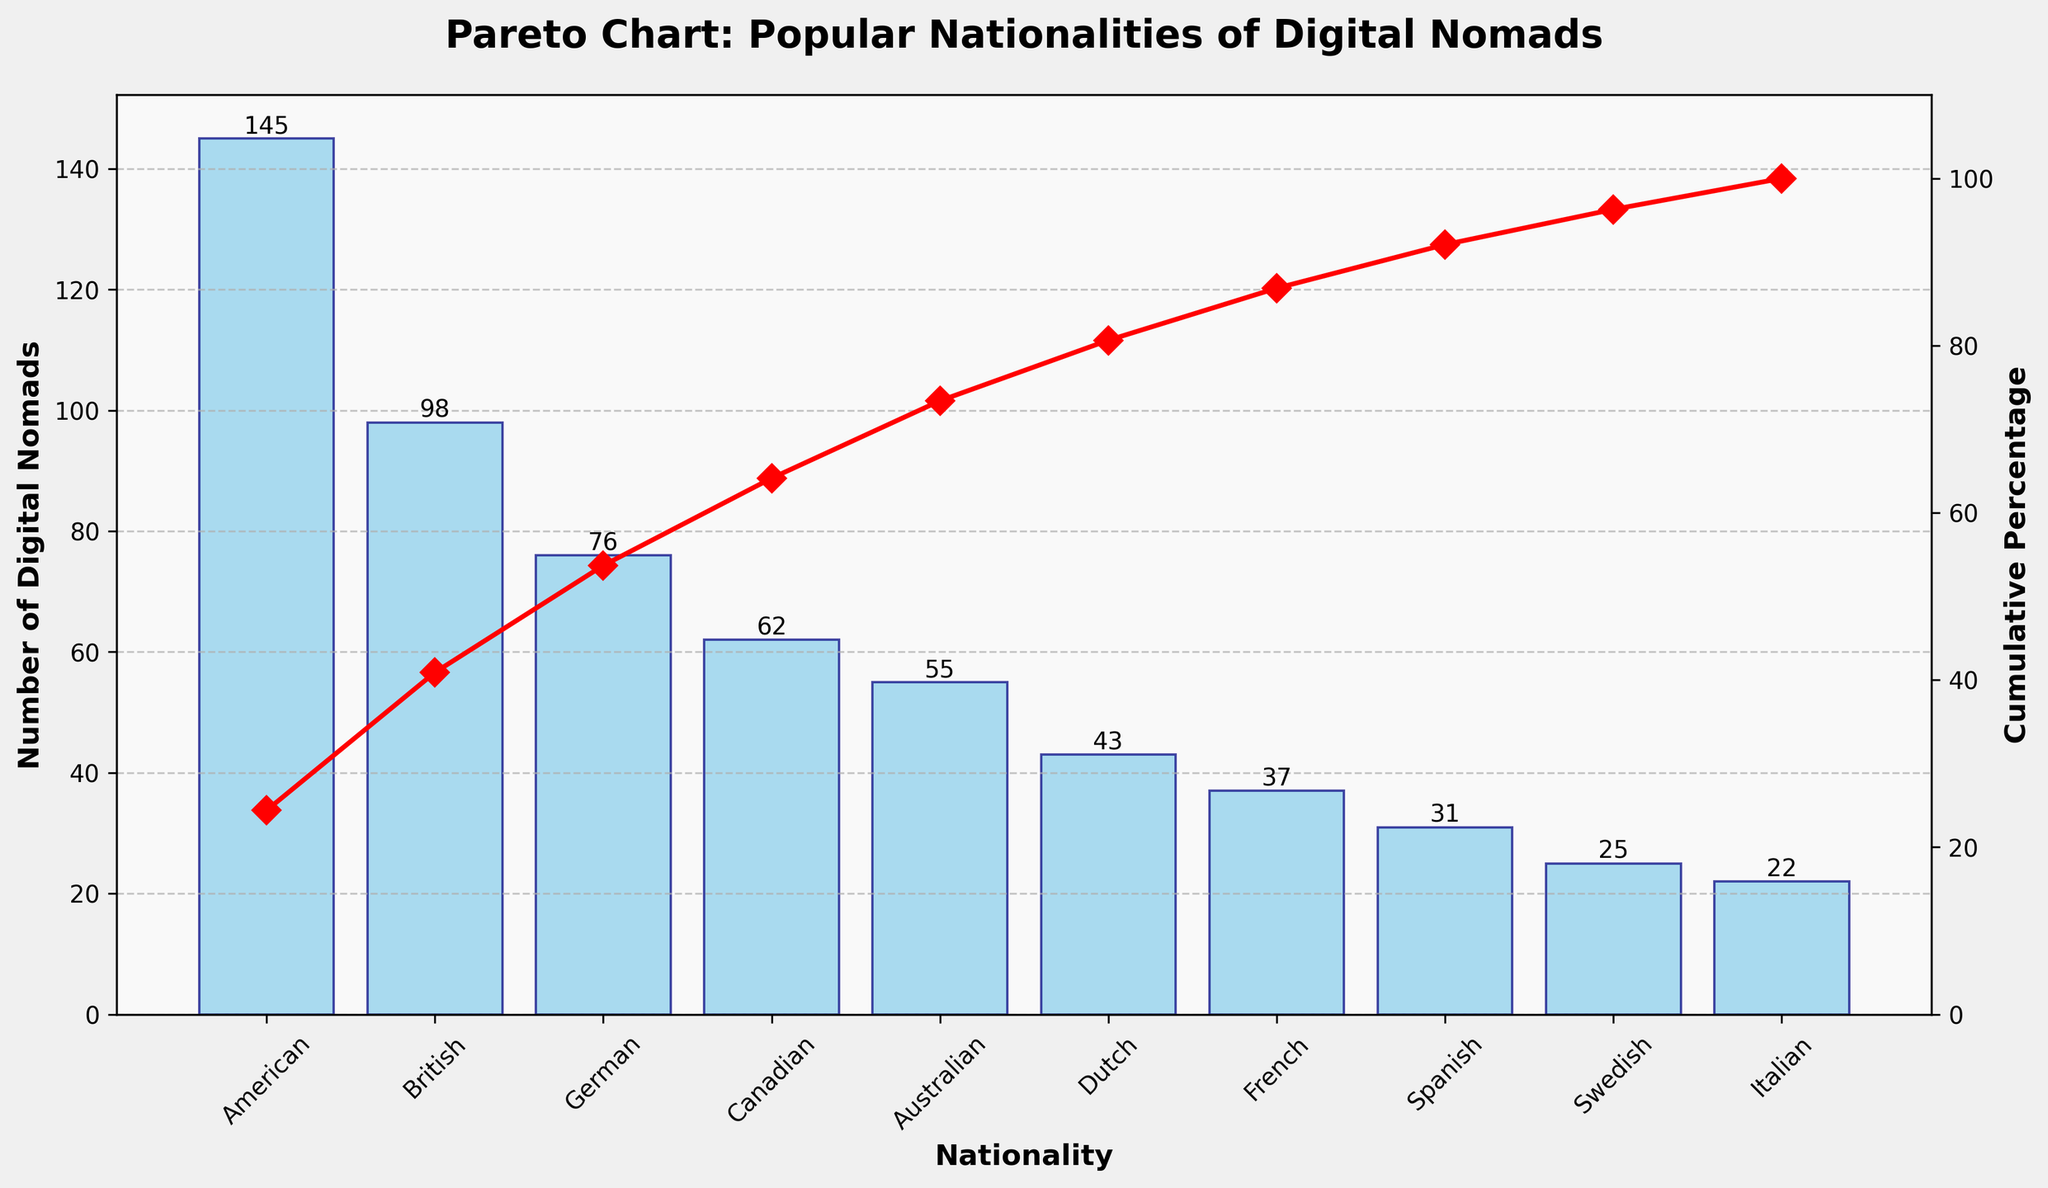What's the title of the figure? The title is usually positioned at the top of the figure and is intended to give a summary of what the figure represents. The title here is "Pareto Chart: Popular Nationalities of Digital Nomads".
Answer: Pareto Chart: Popular Nationalities of Digital Nomads How many nationalities are represented in the chart? The number of bars in a Pareto chart corresponds to the number of distinct nationalities. There are 10 nationalities/bars shown in the chart.
Answer: 10 Which nationality has the highest number of digital nomads? The nationality with the highest number of digital nomads is represented by the tallest bar, which is "American".
Answer: American What is the cumulative percentage after the top two nationalities? To find the cumulative percentage after the top two nationalities, identify the percentages listed for the top two bars and sum them up. The top two nationalities are American (145) and British (98). The cumulative percentage at British is shown as approximately 56%.
Answer: ~56% How many digital nomads are from Canada and Australia combined? To calculate this, sum the number of digital nomads from Canada (62) and Australia (55). 62 + 55 = 117.
Answer: 117 Which nationality has a cumulative percentage just before 60%? Look at the cumulative percentage line. The nationality just before the 60% mark is British, which is around 56%.
Answer: British How many more digital nomads are there from Germany compared to Italy? Subtract the number of digital nomads from Italy (22) from the number from Germany (76). 76 - 22 = 54.
Answer: 54 What is the overall trend shown by the cumulative percentage line? The cumulative percentage line increases more steeply with the first few nationalities and then gradually levels off, illustrating that fewer nationalities contribute to the majority of digital nomads.
Answer: Steep increase then levels off What percentage of digital nomads are from the top three nationalities? Add the number of digital nomads from the top three nationalities: American (145), British (98), German (76). Their sum is 145 + 98 + 76 = 319. Divide this by the total (594) and multiply by 100 to get the percentage: (319/594) * 100 ≈ 53.7%.
Answer: ~53.7% Which nationality is represented by the smallest bar? The shortest bar represents the nationality with the fewest digital nomads, which is Italian (22).
Answer: Italian 